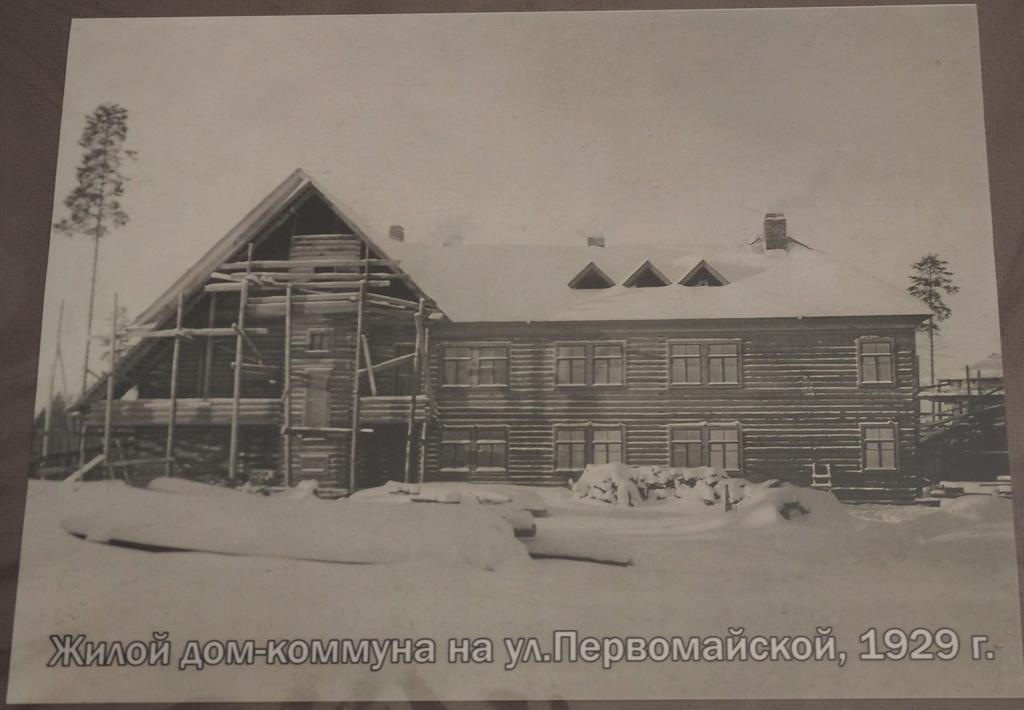Could you give a brief overview of what you see in this image? This is a black and white picture. Here we can see buildings, trees, and snow. At the bottom of the picture we can see something is written on it. 